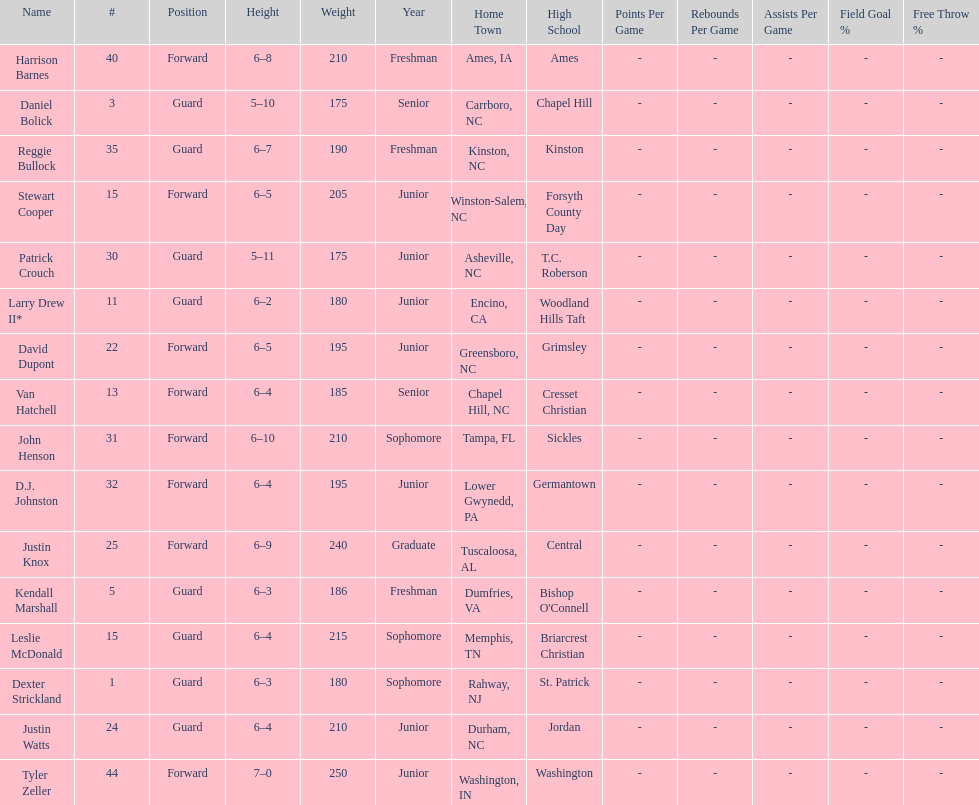Tallest player on the team Tyler Zeller. 